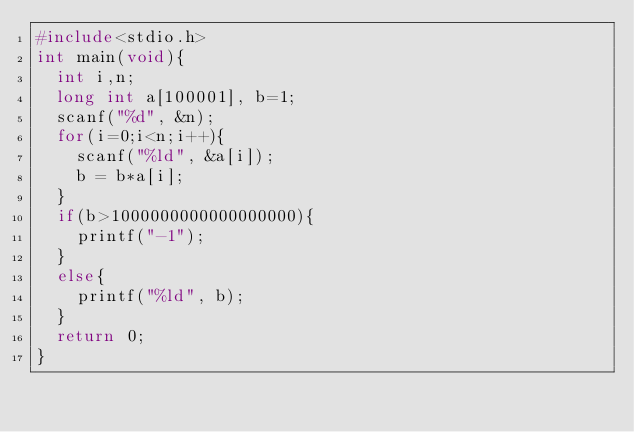<code> <loc_0><loc_0><loc_500><loc_500><_C_>#include<stdio.h>
int main(void){
  int i,n;
  long int a[100001], b=1;
  scanf("%d", &n);
  for(i=0;i<n;i++){
    scanf("%ld", &a[i]);
    b = b*a[i];
  }
  if(b>1000000000000000000){
    printf("-1");
  }
  else{
    printf("%ld", b);
  }
  return 0;
}
    
</code> 